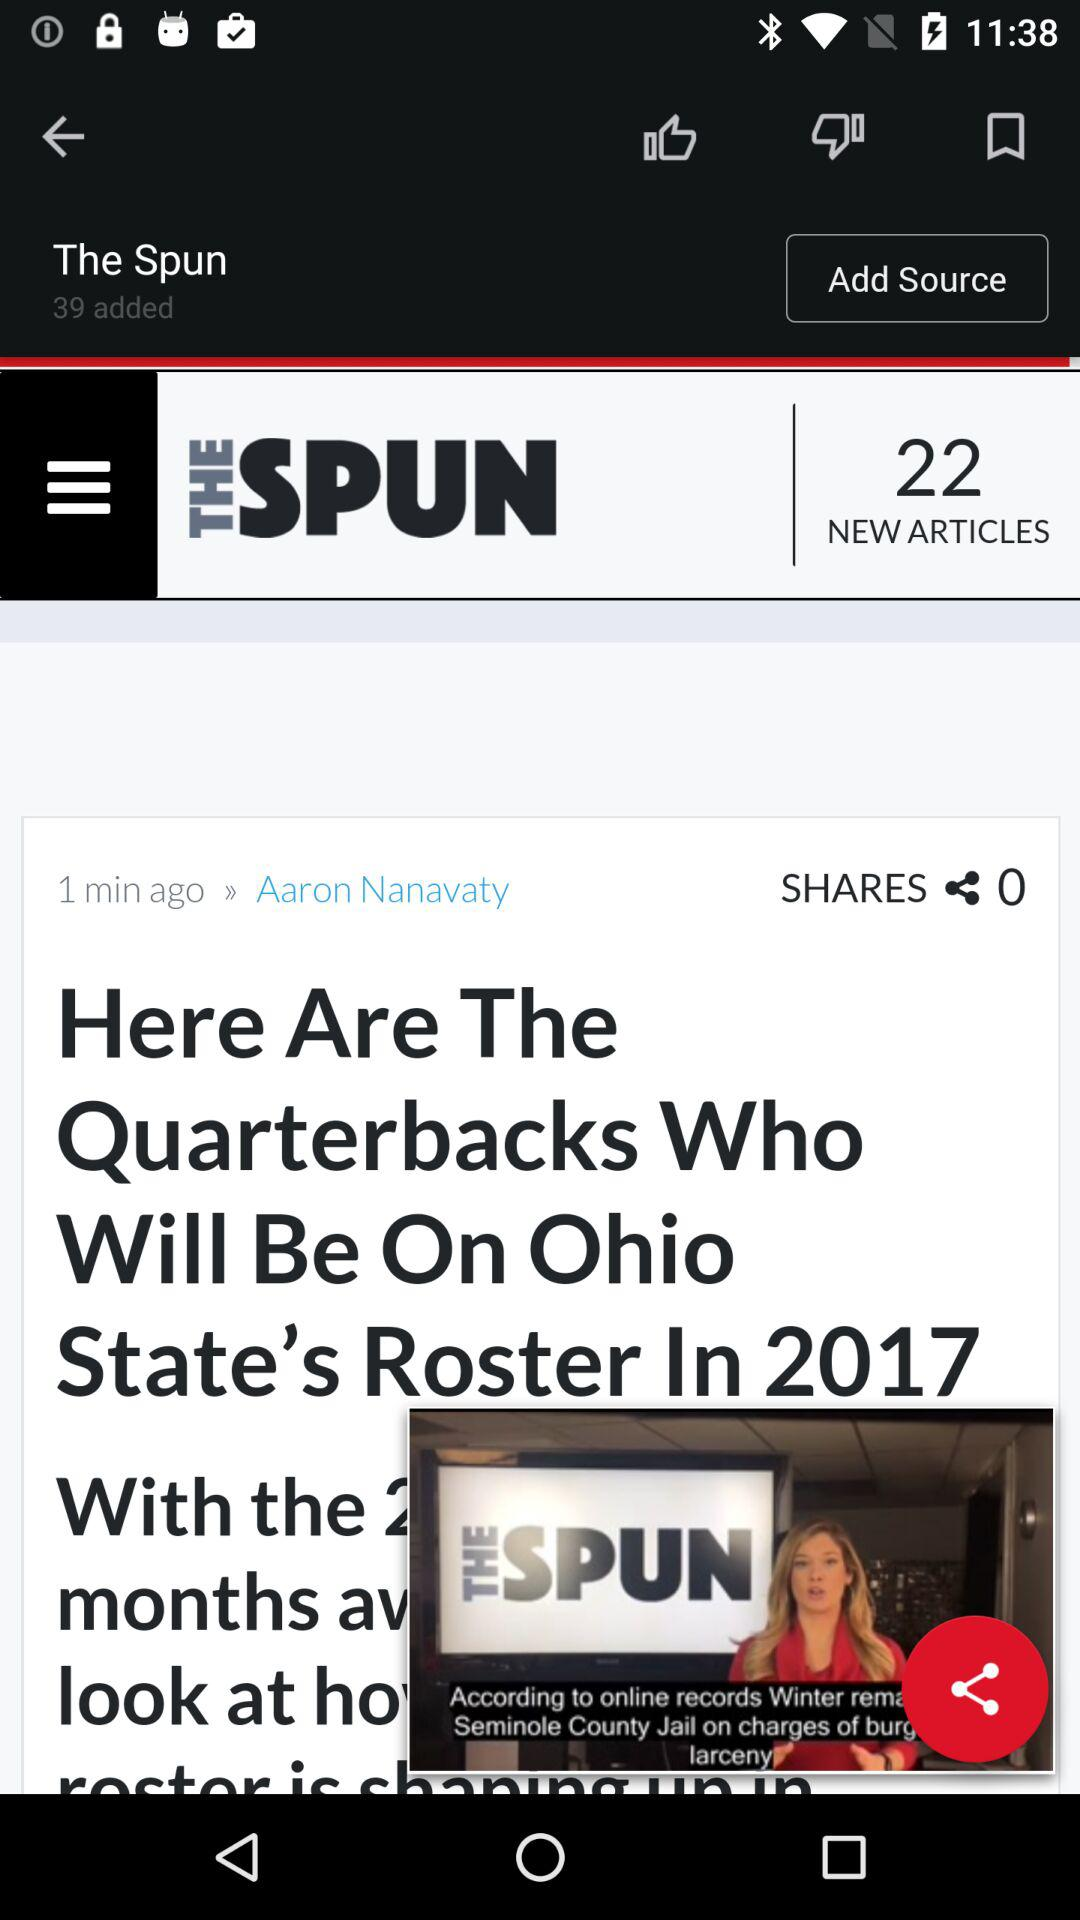Who is the author of the article? The author of the article is Aaron Nanavaty. 